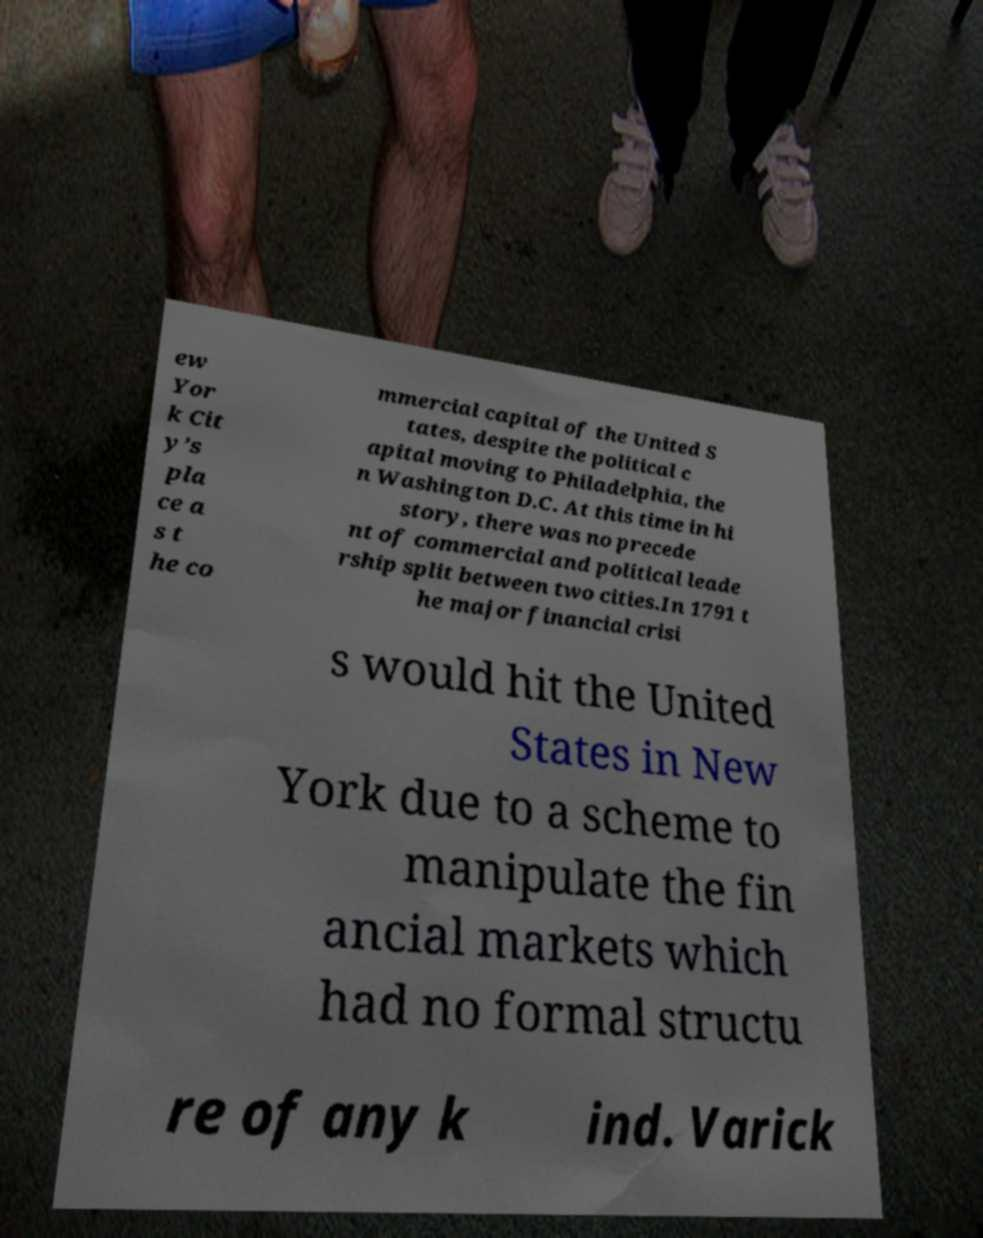For documentation purposes, I need the text within this image transcribed. Could you provide that? ew Yor k Cit y’s pla ce a s t he co mmercial capital of the United S tates, despite the political c apital moving to Philadelphia, the n Washington D.C. At this time in hi story, there was no precede nt of commercial and political leade rship split between two cities.In 1791 t he major financial crisi s would hit the United States in New York due to a scheme to manipulate the fin ancial markets which had no formal structu re of any k ind. Varick 